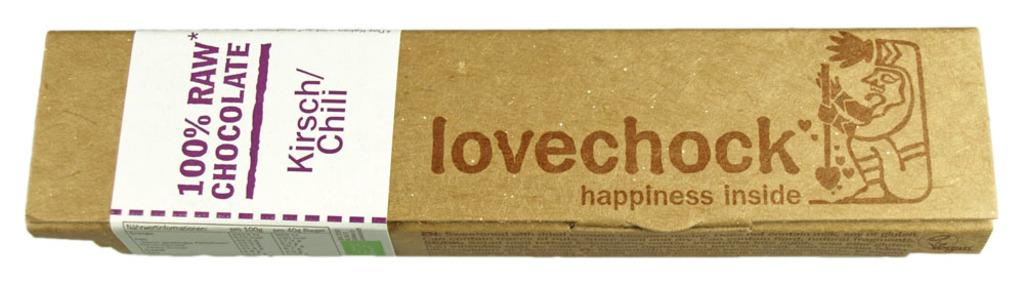<image>
Relay a brief, clear account of the picture shown. The lovechohck bar is made with 100% real chocolate and you can find happiness inside each one. 